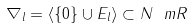<formula> <loc_0><loc_0><loc_500><loc_500>\nabla _ { l } = \left \langle \{ 0 \} \cup E _ { l } \right \rangle \subset N _ { \ } m R</formula> 